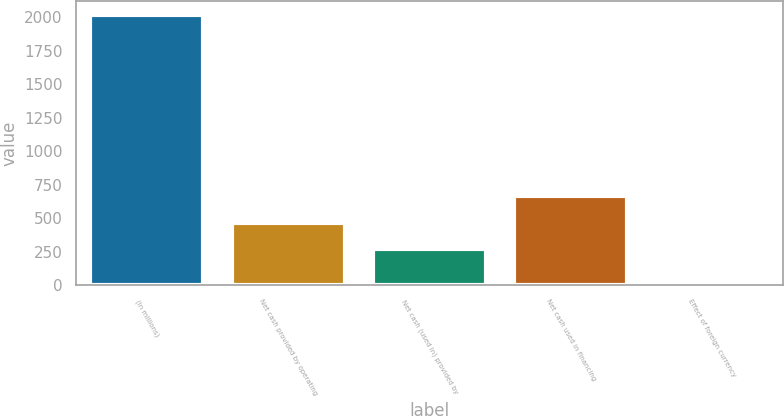Convert chart to OTSL. <chart><loc_0><loc_0><loc_500><loc_500><bar_chart><fcel>(In millions)<fcel>Net cash provided by operating<fcel>Net cash (used in) provided by<fcel>Net cash used in financing<fcel>Effect of foreign currency<nl><fcel>2018<fcel>467.97<fcel>266.7<fcel>669.24<fcel>5.3<nl></chart> 